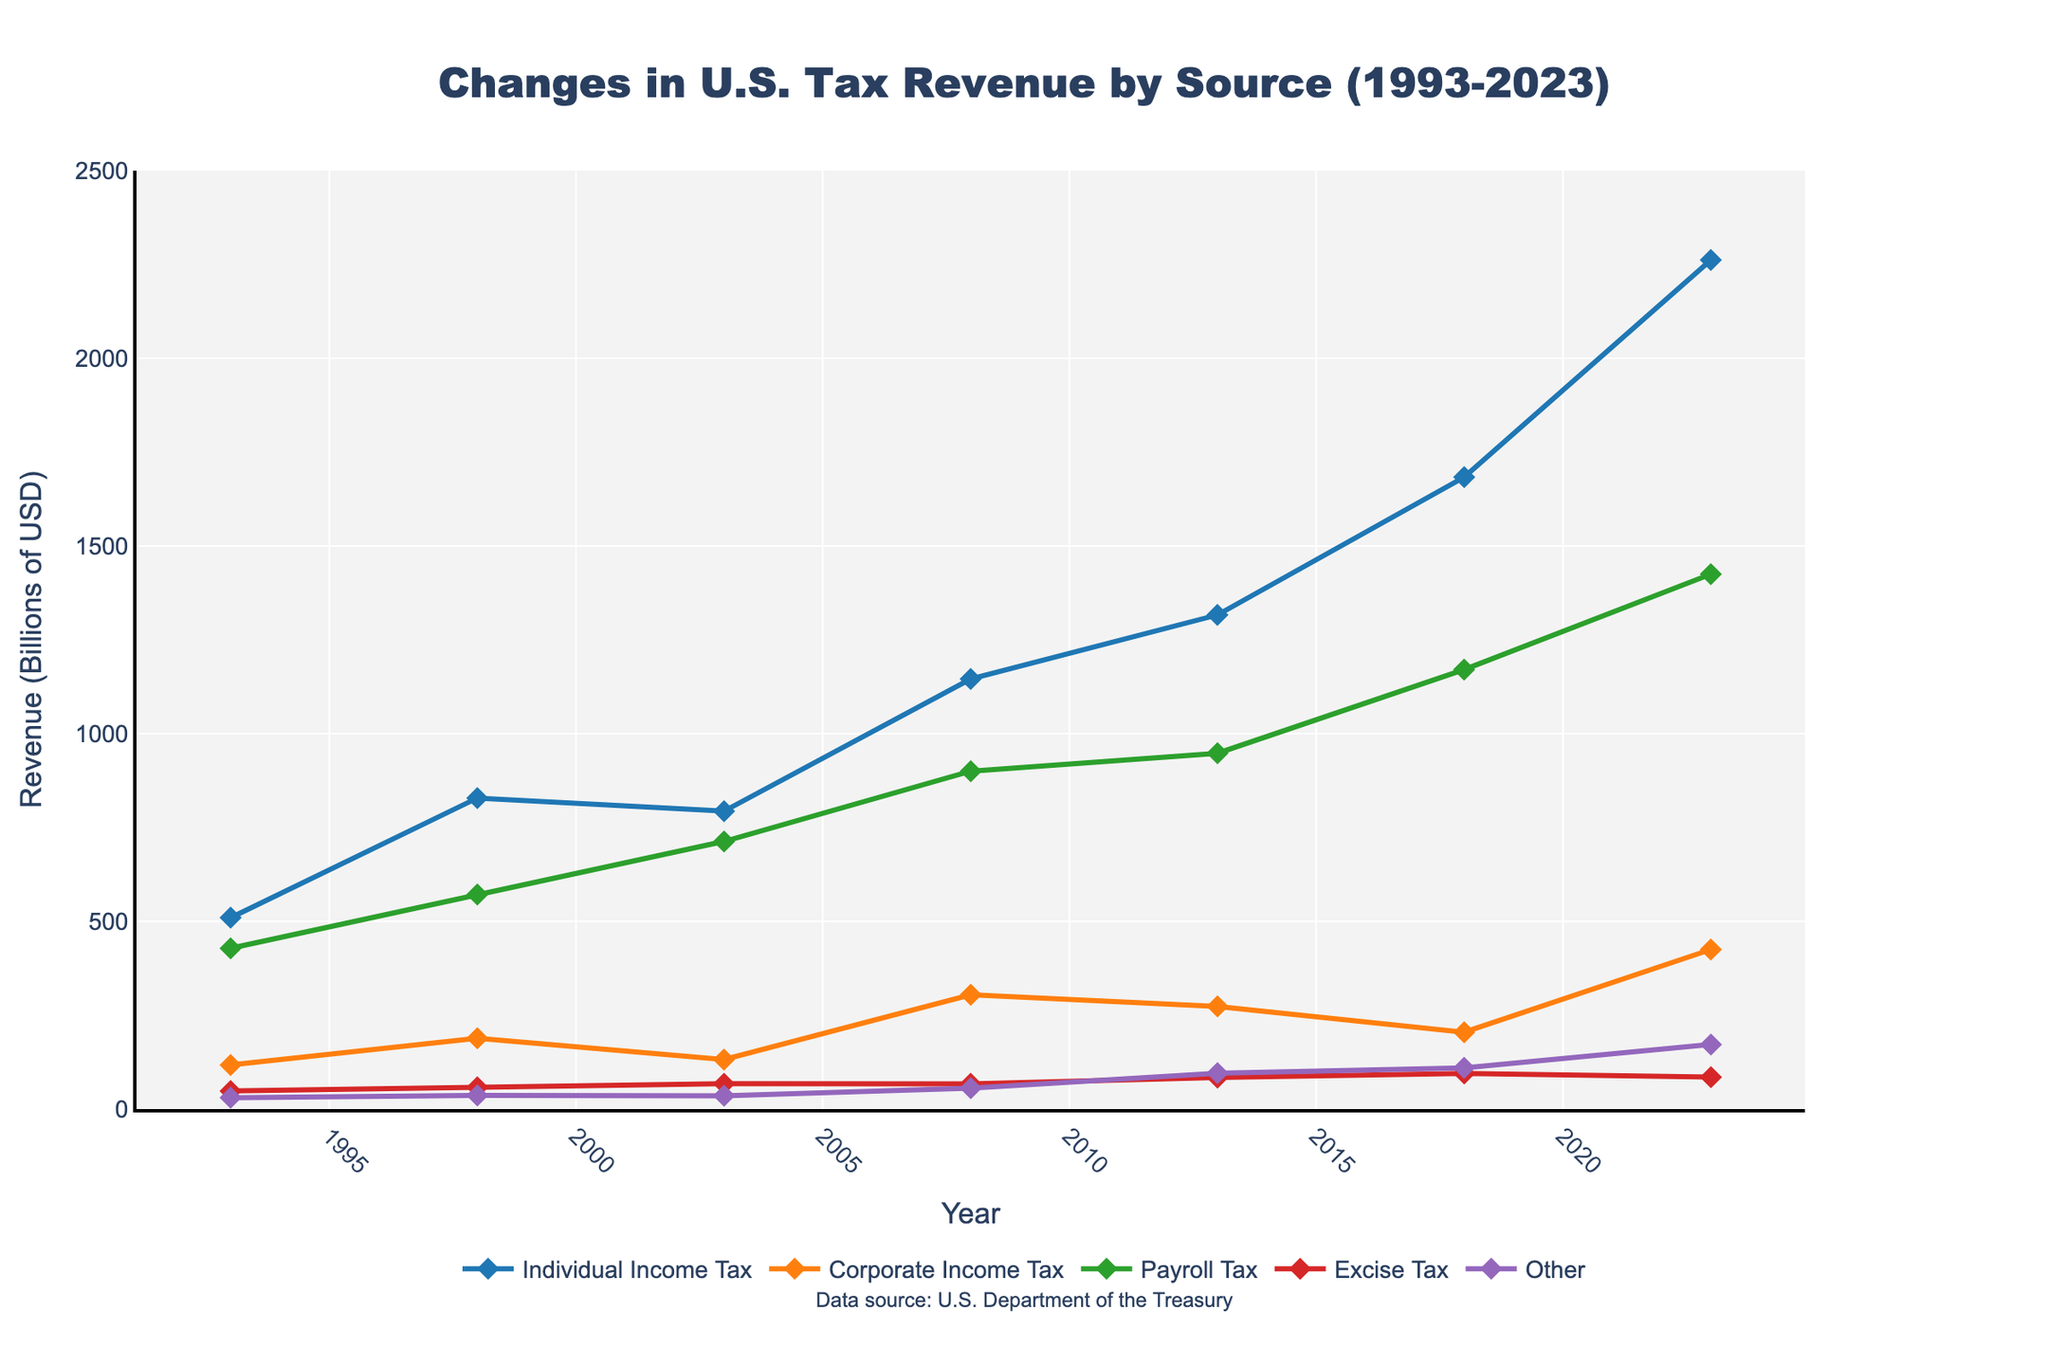When did Payroll Tax first exceed 1 trillion dollars? By examining the line representing Payroll Tax and noting the years on the x-axis, we see that Payroll Tax first exceeds 1 trillion dollars in 2018.
Answer: 2018 How much did Individual Income Tax revenue increase from 1993 to 2023? Find the value of Individual Income Tax revenue in 1993 (509.7 billion USD) and in 2023 (2262 billion USD). Calculate the difference: 2262 - 509.7 = 1752.3 billion USD.
Answer: 1752.3 billion USD Which revenue source saw the most significant absolute increase between 2013 and 2023? Compare the differences for all revenue sources between 2013 and 2023. Individual Income Tax increased by 945.6 billion USD, Corporate Income Tax by 151.5 billion USD, Payroll Tax by 477.2 billion USD, Excise Tax by -1.0 billion USD, and Other by 76.3 billion USD. The greatest increase is for Individual Income Tax.
Answer: Individual Income Tax In 2008, which two revenue sources had the smallest difference in revenue? Compare the revenues for all sources in 2008. Corporate Income Tax was 304.3 billion USD, and Excise Tax was 67.3 billion USD. All other differences are greater than the difference between Corporate Income Tax and Excise Tax.
Answer: Excise Tax and Other How did the Corporate Income Tax revenue change from 1998 to 2003? Find the values from the plot, Corporate Income Tax revenue changed from 188.7 billion USD in 1998 to 131.8 billion USD in 2003, which is a decrease of 56.9 billion USD.
Answer: Decreased by 56.9 billion USD Which source had the highest revenue in 2023 and how much was it? Identify the highest line at 2023 and note its value, which belongs to Individual Income Tax at 2262 billion USD.
Answer: Individual Income Tax; 2262 billion USD Between which two years did Payroll Tax revenue increase the most? Measure the increment between all consecutive years for Payroll Tax. The largest increase is between 2018 (1170.7 billion USD) and 2023 (1425 billion USD), which is 254.3 billion USD.
Answer: 2018 and 2023 In which year did Other revenues first exceed 100 billion dollars? Look at the line for Other and identify the year it first exceeds 100 billion dollars. It happens in 2018 where it reaches 109.8 billion USD.
Answer: 2018 How did Excise Tax revenue change from 2013 to 2018? Check Excise Tax revenue for 2013 (84.0 billion USD) and 2018 (95.0 billion USD), showing an increase of 11 billion USD.
Answer: Increased by 11 billion USD 